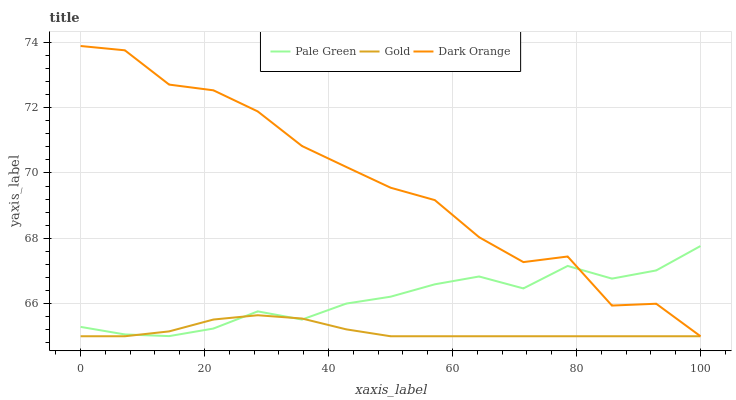Does Gold have the minimum area under the curve?
Answer yes or no. Yes. Does Dark Orange have the maximum area under the curve?
Answer yes or no. Yes. Does Pale Green have the minimum area under the curve?
Answer yes or no. No. Does Pale Green have the maximum area under the curve?
Answer yes or no. No. Is Gold the smoothest?
Answer yes or no. Yes. Is Dark Orange the roughest?
Answer yes or no. Yes. Is Pale Green the smoothest?
Answer yes or no. No. Is Pale Green the roughest?
Answer yes or no. No. Does Pale Green have the lowest value?
Answer yes or no. No. Does Dark Orange have the highest value?
Answer yes or no. Yes. Does Pale Green have the highest value?
Answer yes or no. No. 